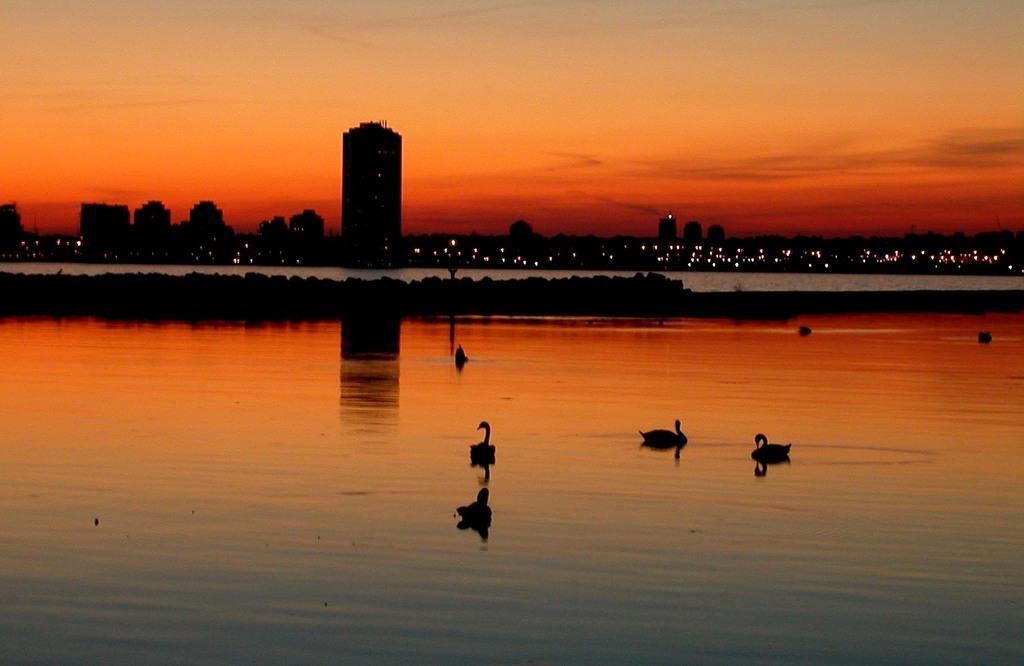Please provide a concise description of this image. Here we can see ducks on the water. In the background there are buildings, lights, and sky. 